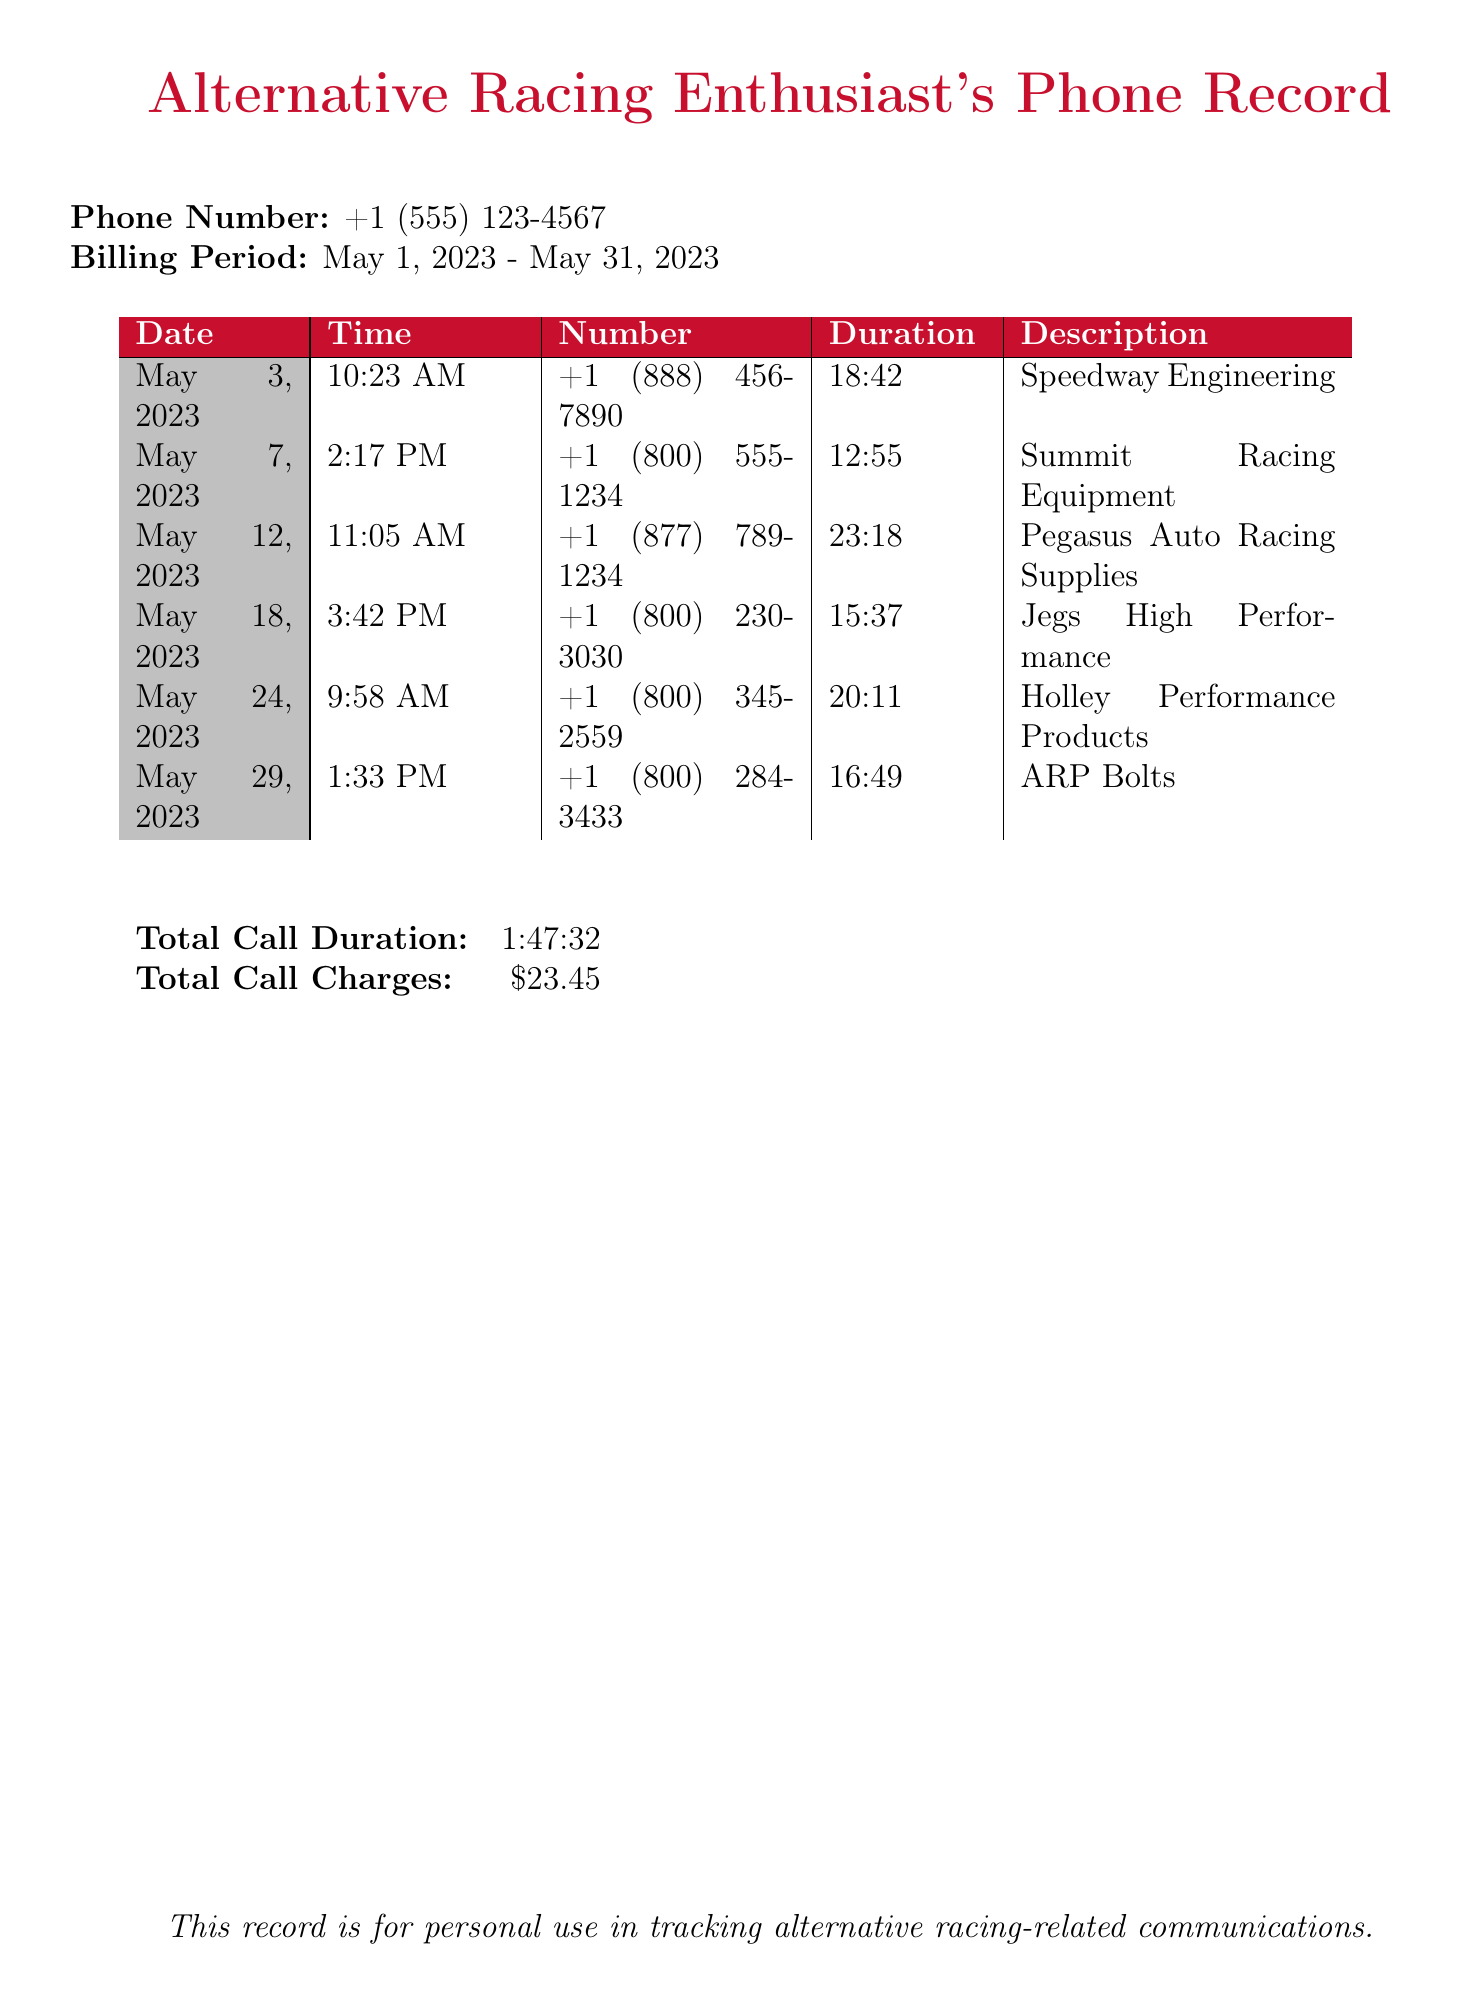What is the phone number in the document? The document displays the phone number +1 (555) 123-4567 at the top.
Answer: +1 (555) 123-4567 What is the billing period covered in the document? The billing period is mentioned as May 1, 2023 - May 31, 2023.
Answer: May 1, 2023 - May 31, 2023 Which supplier was called on May 12, 2023? The record shows the call to Pegasus Auto Racing Supplies on that date.
Answer: Pegasus Auto Racing Supplies What is the total call duration in the document? The document lists the total call duration as 1:47:32.
Answer: 1:47:32 How many minutes did the longest call last? The longest call is from May 12, 2023, lasting 23 minutes and 18 seconds.
Answer: 23:18 What is the total call charge according to the document? The document indicates that the total call charges amount to $23.45.
Answer: $23.45 How many unique suppliers are called in total? There are six different suppliers listed in the call records.
Answer: 6 On what date was the call to Holley Performance Products made? The call to Holley Performance Products occurred on May 24, 2023.
Answer: May 24, 2023 Which supplier had the shortest call duration? The shortest call was with Summit Racing Equipment lasting 12 minutes and 55 seconds.
Answer: Summit Racing Equipment 